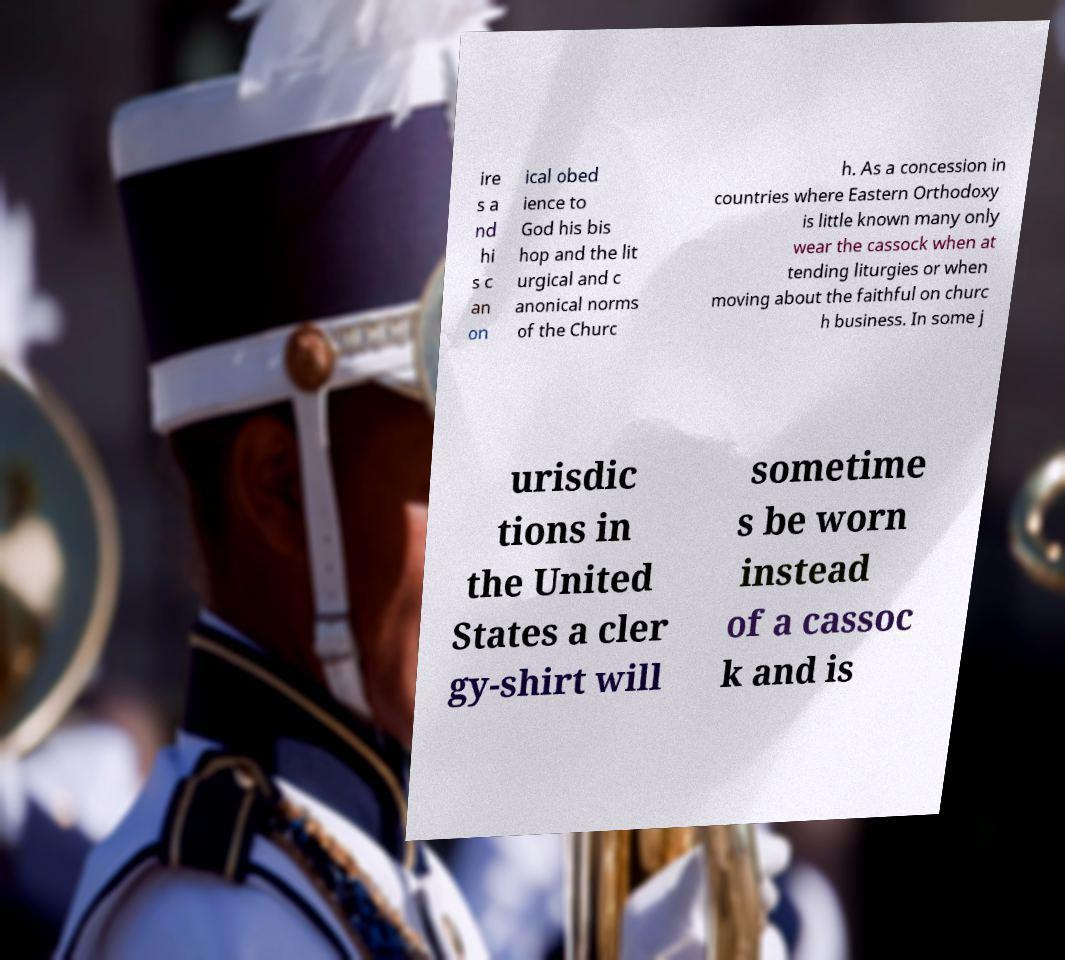Please read and relay the text visible in this image. What does it say? ire s a nd hi s c an on ical obed ience to God his bis hop and the lit urgical and c anonical norms of the Churc h. As a concession in countries where Eastern Orthodoxy is little known many only wear the cassock when at tending liturgies or when moving about the faithful on churc h business. In some j urisdic tions in the United States a cler gy-shirt will sometime s be worn instead of a cassoc k and is 